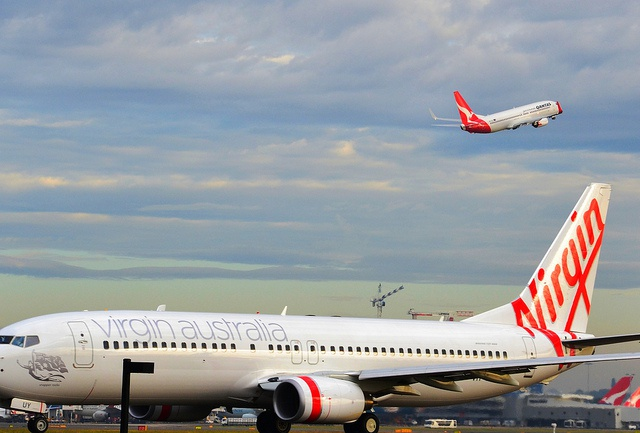Describe the objects in this image and their specific colors. I can see airplane in gray, lightgray, black, darkgray, and tan tones, airplane in gray, darkgray, lightgray, red, and tan tones, airplane in gray, brown, and darkgray tones, and bus in gray, black, and tan tones in this image. 